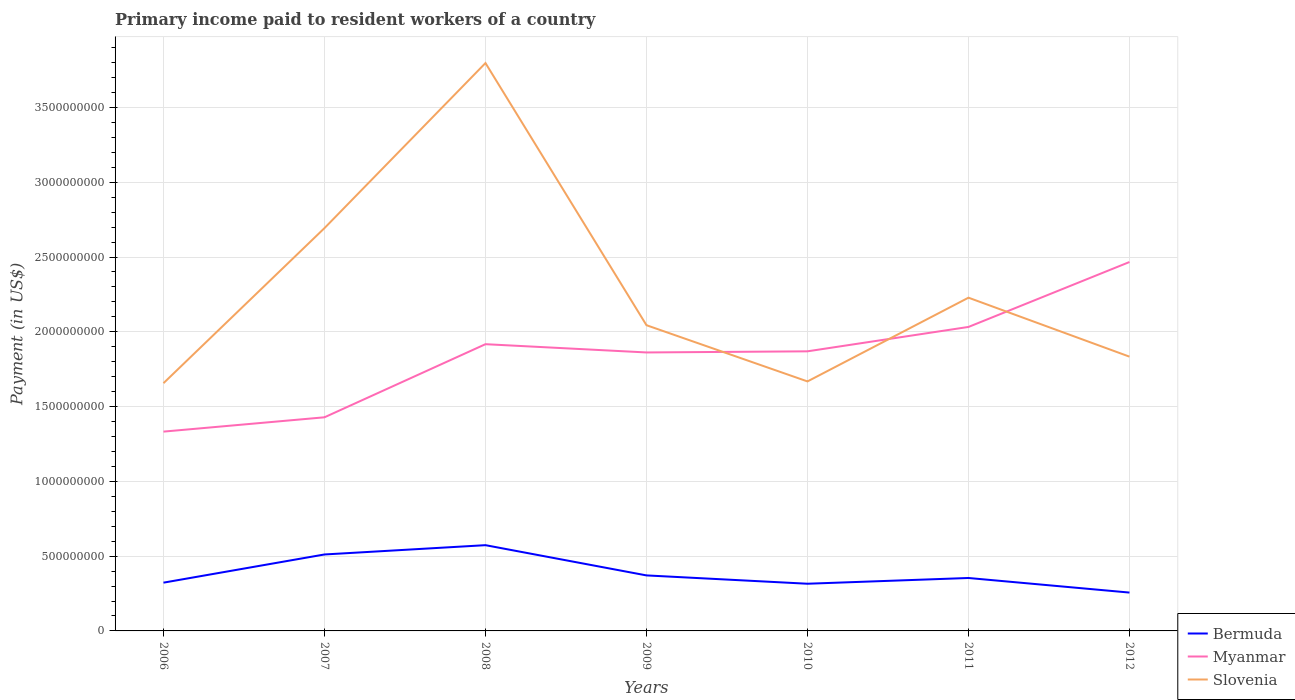How many different coloured lines are there?
Give a very brief answer. 3. Does the line corresponding to Myanmar intersect with the line corresponding to Slovenia?
Your response must be concise. Yes. Is the number of lines equal to the number of legend labels?
Give a very brief answer. Yes. Across all years, what is the maximum amount paid to workers in Slovenia?
Your answer should be compact. 1.66e+09. What is the total amount paid to workers in Bermuda in the graph?
Offer a very short reply. -6.21e+07. What is the difference between the highest and the second highest amount paid to workers in Bermuda?
Offer a terse response. 3.17e+08. What is the difference between the highest and the lowest amount paid to workers in Myanmar?
Provide a short and direct response. 5. Is the amount paid to workers in Bermuda strictly greater than the amount paid to workers in Slovenia over the years?
Keep it short and to the point. Yes. How many lines are there?
Provide a short and direct response. 3. How many years are there in the graph?
Provide a succinct answer. 7. What is the difference between two consecutive major ticks on the Y-axis?
Provide a succinct answer. 5.00e+08. Are the values on the major ticks of Y-axis written in scientific E-notation?
Offer a very short reply. No. Where does the legend appear in the graph?
Provide a short and direct response. Bottom right. How many legend labels are there?
Your answer should be compact. 3. How are the legend labels stacked?
Offer a terse response. Vertical. What is the title of the graph?
Ensure brevity in your answer.  Primary income paid to resident workers of a country. Does "Montenegro" appear as one of the legend labels in the graph?
Offer a terse response. No. What is the label or title of the Y-axis?
Provide a short and direct response. Payment (in US$). What is the Payment (in US$) of Bermuda in 2006?
Your answer should be compact. 3.23e+08. What is the Payment (in US$) in Myanmar in 2006?
Your answer should be very brief. 1.33e+09. What is the Payment (in US$) in Slovenia in 2006?
Your response must be concise. 1.66e+09. What is the Payment (in US$) of Bermuda in 2007?
Ensure brevity in your answer.  5.11e+08. What is the Payment (in US$) of Myanmar in 2007?
Offer a terse response. 1.43e+09. What is the Payment (in US$) of Slovenia in 2007?
Offer a very short reply. 2.69e+09. What is the Payment (in US$) of Bermuda in 2008?
Ensure brevity in your answer.  5.73e+08. What is the Payment (in US$) in Myanmar in 2008?
Offer a terse response. 1.92e+09. What is the Payment (in US$) of Slovenia in 2008?
Provide a succinct answer. 3.80e+09. What is the Payment (in US$) in Bermuda in 2009?
Make the answer very short. 3.71e+08. What is the Payment (in US$) of Myanmar in 2009?
Provide a succinct answer. 1.86e+09. What is the Payment (in US$) of Slovenia in 2009?
Provide a succinct answer. 2.04e+09. What is the Payment (in US$) in Bermuda in 2010?
Provide a succinct answer. 3.15e+08. What is the Payment (in US$) in Myanmar in 2010?
Your response must be concise. 1.87e+09. What is the Payment (in US$) of Slovenia in 2010?
Your answer should be very brief. 1.67e+09. What is the Payment (in US$) of Bermuda in 2011?
Provide a short and direct response. 3.54e+08. What is the Payment (in US$) of Myanmar in 2011?
Your response must be concise. 2.03e+09. What is the Payment (in US$) of Slovenia in 2011?
Keep it short and to the point. 2.23e+09. What is the Payment (in US$) of Bermuda in 2012?
Provide a short and direct response. 2.56e+08. What is the Payment (in US$) in Myanmar in 2012?
Ensure brevity in your answer.  2.47e+09. What is the Payment (in US$) in Slovenia in 2012?
Your answer should be compact. 1.83e+09. Across all years, what is the maximum Payment (in US$) in Bermuda?
Your answer should be compact. 5.73e+08. Across all years, what is the maximum Payment (in US$) in Myanmar?
Your answer should be very brief. 2.47e+09. Across all years, what is the maximum Payment (in US$) in Slovenia?
Ensure brevity in your answer.  3.80e+09. Across all years, what is the minimum Payment (in US$) in Bermuda?
Your response must be concise. 2.56e+08. Across all years, what is the minimum Payment (in US$) in Myanmar?
Your answer should be very brief. 1.33e+09. Across all years, what is the minimum Payment (in US$) of Slovenia?
Provide a short and direct response. 1.66e+09. What is the total Payment (in US$) in Bermuda in the graph?
Your answer should be very brief. 2.70e+09. What is the total Payment (in US$) in Myanmar in the graph?
Your answer should be compact. 1.29e+1. What is the total Payment (in US$) of Slovenia in the graph?
Keep it short and to the point. 1.59e+1. What is the difference between the Payment (in US$) of Bermuda in 2006 and that in 2007?
Offer a terse response. -1.88e+08. What is the difference between the Payment (in US$) in Myanmar in 2006 and that in 2007?
Your response must be concise. -9.57e+07. What is the difference between the Payment (in US$) of Slovenia in 2006 and that in 2007?
Provide a short and direct response. -1.04e+09. What is the difference between the Payment (in US$) of Bermuda in 2006 and that in 2008?
Provide a short and direct response. -2.51e+08. What is the difference between the Payment (in US$) of Myanmar in 2006 and that in 2008?
Give a very brief answer. -5.85e+08. What is the difference between the Payment (in US$) of Slovenia in 2006 and that in 2008?
Make the answer very short. -2.14e+09. What is the difference between the Payment (in US$) of Bermuda in 2006 and that in 2009?
Provide a short and direct response. -4.84e+07. What is the difference between the Payment (in US$) in Myanmar in 2006 and that in 2009?
Your answer should be compact. -5.29e+08. What is the difference between the Payment (in US$) of Slovenia in 2006 and that in 2009?
Give a very brief answer. -3.88e+08. What is the difference between the Payment (in US$) of Bermuda in 2006 and that in 2010?
Offer a very short reply. 7.28e+06. What is the difference between the Payment (in US$) of Myanmar in 2006 and that in 2010?
Your response must be concise. -5.37e+08. What is the difference between the Payment (in US$) of Slovenia in 2006 and that in 2010?
Keep it short and to the point. -1.18e+07. What is the difference between the Payment (in US$) of Bermuda in 2006 and that in 2011?
Ensure brevity in your answer.  -3.11e+07. What is the difference between the Payment (in US$) in Myanmar in 2006 and that in 2011?
Give a very brief answer. -7.00e+08. What is the difference between the Payment (in US$) in Slovenia in 2006 and that in 2011?
Your response must be concise. -5.72e+08. What is the difference between the Payment (in US$) of Bermuda in 2006 and that in 2012?
Ensure brevity in your answer.  6.63e+07. What is the difference between the Payment (in US$) in Myanmar in 2006 and that in 2012?
Provide a succinct answer. -1.13e+09. What is the difference between the Payment (in US$) in Slovenia in 2006 and that in 2012?
Offer a very short reply. -1.77e+08. What is the difference between the Payment (in US$) in Bermuda in 2007 and that in 2008?
Offer a very short reply. -6.21e+07. What is the difference between the Payment (in US$) in Myanmar in 2007 and that in 2008?
Provide a succinct answer. -4.89e+08. What is the difference between the Payment (in US$) of Slovenia in 2007 and that in 2008?
Make the answer very short. -1.10e+09. What is the difference between the Payment (in US$) in Bermuda in 2007 and that in 2009?
Offer a very short reply. 1.40e+08. What is the difference between the Payment (in US$) of Myanmar in 2007 and that in 2009?
Your answer should be compact. -4.34e+08. What is the difference between the Payment (in US$) of Slovenia in 2007 and that in 2009?
Provide a short and direct response. 6.49e+08. What is the difference between the Payment (in US$) in Bermuda in 2007 and that in 2010?
Your response must be concise. 1.96e+08. What is the difference between the Payment (in US$) in Myanmar in 2007 and that in 2010?
Offer a terse response. -4.41e+08. What is the difference between the Payment (in US$) in Slovenia in 2007 and that in 2010?
Provide a short and direct response. 1.03e+09. What is the difference between the Payment (in US$) of Bermuda in 2007 and that in 2011?
Your response must be concise. 1.57e+08. What is the difference between the Payment (in US$) of Myanmar in 2007 and that in 2011?
Offer a very short reply. -6.04e+08. What is the difference between the Payment (in US$) in Slovenia in 2007 and that in 2011?
Give a very brief answer. 4.65e+08. What is the difference between the Payment (in US$) of Bermuda in 2007 and that in 2012?
Keep it short and to the point. 2.55e+08. What is the difference between the Payment (in US$) of Myanmar in 2007 and that in 2012?
Ensure brevity in your answer.  -1.04e+09. What is the difference between the Payment (in US$) in Slovenia in 2007 and that in 2012?
Offer a very short reply. 8.59e+08. What is the difference between the Payment (in US$) in Bermuda in 2008 and that in 2009?
Make the answer very short. 2.02e+08. What is the difference between the Payment (in US$) in Myanmar in 2008 and that in 2009?
Keep it short and to the point. 5.53e+07. What is the difference between the Payment (in US$) of Slovenia in 2008 and that in 2009?
Provide a succinct answer. 1.75e+09. What is the difference between the Payment (in US$) of Bermuda in 2008 and that in 2010?
Offer a terse response. 2.58e+08. What is the difference between the Payment (in US$) of Myanmar in 2008 and that in 2010?
Make the answer very short. 4.77e+07. What is the difference between the Payment (in US$) in Slovenia in 2008 and that in 2010?
Your answer should be compact. 2.13e+09. What is the difference between the Payment (in US$) in Bermuda in 2008 and that in 2011?
Make the answer very short. 2.19e+08. What is the difference between the Payment (in US$) in Myanmar in 2008 and that in 2011?
Your response must be concise. -1.15e+08. What is the difference between the Payment (in US$) of Slovenia in 2008 and that in 2011?
Your answer should be compact. 1.57e+09. What is the difference between the Payment (in US$) of Bermuda in 2008 and that in 2012?
Provide a succinct answer. 3.17e+08. What is the difference between the Payment (in US$) of Myanmar in 2008 and that in 2012?
Give a very brief answer. -5.49e+08. What is the difference between the Payment (in US$) of Slovenia in 2008 and that in 2012?
Your response must be concise. 1.96e+09. What is the difference between the Payment (in US$) of Bermuda in 2009 and that in 2010?
Your answer should be very brief. 5.57e+07. What is the difference between the Payment (in US$) of Myanmar in 2009 and that in 2010?
Provide a succinct answer. -7.55e+06. What is the difference between the Payment (in US$) of Slovenia in 2009 and that in 2010?
Ensure brevity in your answer.  3.76e+08. What is the difference between the Payment (in US$) in Bermuda in 2009 and that in 2011?
Make the answer very short. 1.72e+07. What is the difference between the Payment (in US$) in Myanmar in 2009 and that in 2011?
Keep it short and to the point. -1.71e+08. What is the difference between the Payment (in US$) of Slovenia in 2009 and that in 2011?
Offer a very short reply. -1.84e+08. What is the difference between the Payment (in US$) of Bermuda in 2009 and that in 2012?
Your answer should be compact. 1.15e+08. What is the difference between the Payment (in US$) in Myanmar in 2009 and that in 2012?
Offer a very short reply. -6.05e+08. What is the difference between the Payment (in US$) in Slovenia in 2009 and that in 2012?
Offer a very short reply. 2.10e+08. What is the difference between the Payment (in US$) of Bermuda in 2010 and that in 2011?
Ensure brevity in your answer.  -3.84e+07. What is the difference between the Payment (in US$) of Myanmar in 2010 and that in 2011?
Your answer should be very brief. -1.63e+08. What is the difference between the Payment (in US$) of Slovenia in 2010 and that in 2011?
Your answer should be very brief. -5.60e+08. What is the difference between the Payment (in US$) of Bermuda in 2010 and that in 2012?
Give a very brief answer. 5.90e+07. What is the difference between the Payment (in US$) of Myanmar in 2010 and that in 2012?
Your answer should be compact. -5.97e+08. What is the difference between the Payment (in US$) of Slovenia in 2010 and that in 2012?
Your answer should be compact. -1.66e+08. What is the difference between the Payment (in US$) of Bermuda in 2011 and that in 2012?
Your answer should be compact. 9.75e+07. What is the difference between the Payment (in US$) of Myanmar in 2011 and that in 2012?
Provide a succinct answer. -4.34e+08. What is the difference between the Payment (in US$) of Slovenia in 2011 and that in 2012?
Ensure brevity in your answer.  3.94e+08. What is the difference between the Payment (in US$) in Bermuda in 2006 and the Payment (in US$) in Myanmar in 2007?
Offer a terse response. -1.11e+09. What is the difference between the Payment (in US$) of Bermuda in 2006 and the Payment (in US$) of Slovenia in 2007?
Offer a terse response. -2.37e+09. What is the difference between the Payment (in US$) of Myanmar in 2006 and the Payment (in US$) of Slovenia in 2007?
Provide a succinct answer. -1.36e+09. What is the difference between the Payment (in US$) in Bermuda in 2006 and the Payment (in US$) in Myanmar in 2008?
Provide a succinct answer. -1.59e+09. What is the difference between the Payment (in US$) of Bermuda in 2006 and the Payment (in US$) of Slovenia in 2008?
Provide a succinct answer. -3.47e+09. What is the difference between the Payment (in US$) in Myanmar in 2006 and the Payment (in US$) in Slovenia in 2008?
Make the answer very short. -2.46e+09. What is the difference between the Payment (in US$) of Bermuda in 2006 and the Payment (in US$) of Myanmar in 2009?
Your answer should be very brief. -1.54e+09. What is the difference between the Payment (in US$) of Bermuda in 2006 and the Payment (in US$) of Slovenia in 2009?
Give a very brief answer. -1.72e+09. What is the difference between the Payment (in US$) of Myanmar in 2006 and the Payment (in US$) of Slovenia in 2009?
Offer a terse response. -7.11e+08. What is the difference between the Payment (in US$) of Bermuda in 2006 and the Payment (in US$) of Myanmar in 2010?
Offer a terse response. -1.55e+09. What is the difference between the Payment (in US$) in Bermuda in 2006 and the Payment (in US$) in Slovenia in 2010?
Ensure brevity in your answer.  -1.35e+09. What is the difference between the Payment (in US$) in Myanmar in 2006 and the Payment (in US$) in Slovenia in 2010?
Ensure brevity in your answer.  -3.36e+08. What is the difference between the Payment (in US$) in Bermuda in 2006 and the Payment (in US$) in Myanmar in 2011?
Your answer should be compact. -1.71e+09. What is the difference between the Payment (in US$) of Bermuda in 2006 and the Payment (in US$) of Slovenia in 2011?
Offer a terse response. -1.91e+09. What is the difference between the Payment (in US$) in Myanmar in 2006 and the Payment (in US$) in Slovenia in 2011?
Keep it short and to the point. -8.95e+08. What is the difference between the Payment (in US$) in Bermuda in 2006 and the Payment (in US$) in Myanmar in 2012?
Provide a succinct answer. -2.14e+09. What is the difference between the Payment (in US$) in Bermuda in 2006 and the Payment (in US$) in Slovenia in 2012?
Ensure brevity in your answer.  -1.51e+09. What is the difference between the Payment (in US$) of Myanmar in 2006 and the Payment (in US$) of Slovenia in 2012?
Give a very brief answer. -5.01e+08. What is the difference between the Payment (in US$) of Bermuda in 2007 and the Payment (in US$) of Myanmar in 2008?
Provide a short and direct response. -1.41e+09. What is the difference between the Payment (in US$) in Bermuda in 2007 and the Payment (in US$) in Slovenia in 2008?
Your answer should be compact. -3.29e+09. What is the difference between the Payment (in US$) in Myanmar in 2007 and the Payment (in US$) in Slovenia in 2008?
Ensure brevity in your answer.  -2.37e+09. What is the difference between the Payment (in US$) in Bermuda in 2007 and the Payment (in US$) in Myanmar in 2009?
Your answer should be compact. -1.35e+09. What is the difference between the Payment (in US$) in Bermuda in 2007 and the Payment (in US$) in Slovenia in 2009?
Provide a succinct answer. -1.53e+09. What is the difference between the Payment (in US$) in Myanmar in 2007 and the Payment (in US$) in Slovenia in 2009?
Keep it short and to the point. -6.16e+08. What is the difference between the Payment (in US$) in Bermuda in 2007 and the Payment (in US$) in Myanmar in 2010?
Your answer should be very brief. -1.36e+09. What is the difference between the Payment (in US$) of Bermuda in 2007 and the Payment (in US$) of Slovenia in 2010?
Provide a succinct answer. -1.16e+09. What is the difference between the Payment (in US$) in Myanmar in 2007 and the Payment (in US$) in Slovenia in 2010?
Offer a very short reply. -2.40e+08. What is the difference between the Payment (in US$) in Bermuda in 2007 and the Payment (in US$) in Myanmar in 2011?
Give a very brief answer. -1.52e+09. What is the difference between the Payment (in US$) in Bermuda in 2007 and the Payment (in US$) in Slovenia in 2011?
Keep it short and to the point. -1.72e+09. What is the difference between the Payment (in US$) in Myanmar in 2007 and the Payment (in US$) in Slovenia in 2011?
Offer a very short reply. -8.00e+08. What is the difference between the Payment (in US$) of Bermuda in 2007 and the Payment (in US$) of Myanmar in 2012?
Offer a terse response. -1.96e+09. What is the difference between the Payment (in US$) of Bermuda in 2007 and the Payment (in US$) of Slovenia in 2012?
Make the answer very short. -1.32e+09. What is the difference between the Payment (in US$) in Myanmar in 2007 and the Payment (in US$) in Slovenia in 2012?
Your response must be concise. -4.05e+08. What is the difference between the Payment (in US$) in Bermuda in 2008 and the Payment (in US$) in Myanmar in 2009?
Your response must be concise. -1.29e+09. What is the difference between the Payment (in US$) of Bermuda in 2008 and the Payment (in US$) of Slovenia in 2009?
Offer a terse response. -1.47e+09. What is the difference between the Payment (in US$) of Myanmar in 2008 and the Payment (in US$) of Slovenia in 2009?
Your response must be concise. -1.27e+08. What is the difference between the Payment (in US$) in Bermuda in 2008 and the Payment (in US$) in Myanmar in 2010?
Provide a short and direct response. -1.30e+09. What is the difference between the Payment (in US$) in Bermuda in 2008 and the Payment (in US$) in Slovenia in 2010?
Offer a terse response. -1.09e+09. What is the difference between the Payment (in US$) in Myanmar in 2008 and the Payment (in US$) in Slovenia in 2010?
Provide a short and direct response. 2.49e+08. What is the difference between the Payment (in US$) in Bermuda in 2008 and the Payment (in US$) in Myanmar in 2011?
Keep it short and to the point. -1.46e+09. What is the difference between the Payment (in US$) of Bermuda in 2008 and the Payment (in US$) of Slovenia in 2011?
Your answer should be compact. -1.65e+09. What is the difference between the Payment (in US$) of Myanmar in 2008 and the Payment (in US$) of Slovenia in 2011?
Your answer should be very brief. -3.11e+08. What is the difference between the Payment (in US$) in Bermuda in 2008 and the Payment (in US$) in Myanmar in 2012?
Your answer should be compact. -1.89e+09. What is the difference between the Payment (in US$) of Bermuda in 2008 and the Payment (in US$) of Slovenia in 2012?
Your response must be concise. -1.26e+09. What is the difference between the Payment (in US$) of Myanmar in 2008 and the Payment (in US$) of Slovenia in 2012?
Your answer should be very brief. 8.34e+07. What is the difference between the Payment (in US$) in Bermuda in 2009 and the Payment (in US$) in Myanmar in 2010?
Make the answer very short. -1.50e+09. What is the difference between the Payment (in US$) of Bermuda in 2009 and the Payment (in US$) of Slovenia in 2010?
Give a very brief answer. -1.30e+09. What is the difference between the Payment (in US$) of Myanmar in 2009 and the Payment (in US$) of Slovenia in 2010?
Keep it short and to the point. 1.94e+08. What is the difference between the Payment (in US$) of Bermuda in 2009 and the Payment (in US$) of Myanmar in 2011?
Offer a very short reply. -1.66e+09. What is the difference between the Payment (in US$) of Bermuda in 2009 and the Payment (in US$) of Slovenia in 2011?
Give a very brief answer. -1.86e+09. What is the difference between the Payment (in US$) in Myanmar in 2009 and the Payment (in US$) in Slovenia in 2011?
Your answer should be very brief. -3.66e+08. What is the difference between the Payment (in US$) in Bermuda in 2009 and the Payment (in US$) in Myanmar in 2012?
Provide a short and direct response. -2.10e+09. What is the difference between the Payment (in US$) of Bermuda in 2009 and the Payment (in US$) of Slovenia in 2012?
Your response must be concise. -1.46e+09. What is the difference between the Payment (in US$) in Myanmar in 2009 and the Payment (in US$) in Slovenia in 2012?
Provide a short and direct response. 2.81e+07. What is the difference between the Payment (in US$) of Bermuda in 2010 and the Payment (in US$) of Myanmar in 2011?
Provide a short and direct response. -1.72e+09. What is the difference between the Payment (in US$) in Bermuda in 2010 and the Payment (in US$) in Slovenia in 2011?
Offer a very short reply. -1.91e+09. What is the difference between the Payment (in US$) in Myanmar in 2010 and the Payment (in US$) in Slovenia in 2011?
Ensure brevity in your answer.  -3.59e+08. What is the difference between the Payment (in US$) of Bermuda in 2010 and the Payment (in US$) of Myanmar in 2012?
Provide a short and direct response. -2.15e+09. What is the difference between the Payment (in US$) of Bermuda in 2010 and the Payment (in US$) of Slovenia in 2012?
Your response must be concise. -1.52e+09. What is the difference between the Payment (in US$) of Myanmar in 2010 and the Payment (in US$) of Slovenia in 2012?
Offer a terse response. 3.56e+07. What is the difference between the Payment (in US$) in Bermuda in 2011 and the Payment (in US$) in Myanmar in 2012?
Provide a short and direct response. -2.11e+09. What is the difference between the Payment (in US$) of Bermuda in 2011 and the Payment (in US$) of Slovenia in 2012?
Ensure brevity in your answer.  -1.48e+09. What is the difference between the Payment (in US$) of Myanmar in 2011 and the Payment (in US$) of Slovenia in 2012?
Make the answer very short. 1.99e+08. What is the average Payment (in US$) of Bermuda per year?
Provide a short and direct response. 3.86e+08. What is the average Payment (in US$) in Myanmar per year?
Ensure brevity in your answer.  1.84e+09. What is the average Payment (in US$) of Slovenia per year?
Your answer should be compact. 2.27e+09. In the year 2006, what is the difference between the Payment (in US$) of Bermuda and Payment (in US$) of Myanmar?
Offer a terse response. -1.01e+09. In the year 2006, what is the difference between the Payment (in US$) in Bermuda and Payment (in US$) in Slovenia?
Offer a very short reply. -1.33e+09. In the year 2006, what is the difference between the Payment (in US$) in Myanmar and Payment (in US$) in Slovenia?
Your answer should be very brief. -3.24e+08. In the year 2007, what is the difference between the Payment (in US$) in Bermuda and Payment (in US$) in Myanmar?
Ensure brevity in your answer.  -9.17e+08. In the year 2007, what is the difference between the Payment (in US$) of Bermuda and Payment (in US$) of Slovenia?
Your answer should be very brief. -2.18e+09. In the year 2007, what is the difference between the Payment (in US$) of Myanmar and Payment (in US$) of Slovenia?
Your response must be concise. -1.26e+09. In the year 2008, what is the difference between the Payment (in US$) in Bermuda and Payment (in US$) in Myanmar?
Offer a very short reply. -1.34e+09. In the year 2008, what is the difference between the Payment (in US$) in Bermuda and Payment (in US$) in Slovenia?
Provide a short and direct response. -3.22e+09. In the year 2008, what is the difference between the Payment (in US$) in Myanmar and Payment (in US$) in Slovenia?
Give a very brief answer. -1.88e+09. In the year 2009, what is the difference between the Payment (in US$) in Bermuda and Payment (in US$) in Myanmar?
Offer a very short reply. -1.49e+09. In the year 2009, what is the difference between the Payment (in US$) of Bermuda and Payment (in US$) of Slovenia?
Keep it short and to the point. -1.67e+09. In the year 2009, what is the difference between the Payment (in US$) of Myanmar and Payment (in US$) of Slovenia?
Offer a terse response. -1.82e+08. In the year 2010, what is the difference between the Payment (in US$) of Bermuda and Payment (in US$) of Myanmar?
Ensure brevity in your answer.  -1.55e+09. In the year 2010, what is the difference between the Payment (in US$) in Bermuda and Payment (in US$) in Slovenia?
Your answer should be very brief. -1.35e+09. In the year 2010, what is the difference between the Payment (in US$) of Myanmar and Payment (in US$) of Slovenia?
Your answer should be very brief. 2.01e+08. In the year 2011, what is the difference between the Payment (in US$) of Bermuda and Payment (in US$) of Myanmar?
Offer a terse response. -1.68e+09. In the year 2011, what is the difference between the Payment (in US$) of Bermuda and Payment (in US$) of Slovenia?
Provide a short and direct response. -1.87e+09. In the year 2011, what is the difference between the Payment (in US$) of Myanmar and Payment (in US$) of Slovenia?
Give a very brief answer. -1.96e+08. In the year 2012, what is the difference between the Payment (in US$) of Bermuda and Payment (in US$) of Myanmar?
Provide a succinct answer. -2.21e+09. In the year 2012, what is the difference between the Payment (in US$) in Bermuda and Payment (in US$) in Slovenia?
Your answer should be very brief. -1.58e+09. In the year 2012, what is the difference between the Payment (in US$) of Myanmar and Payment (in US$) of Slovenia?
Keep it short and to the point. 6.33e+08. What is the ratio of the Payment (in US$) in Bermuda in 2006 to that in 2007?
Your response must be concise. 0.63. What is the ratio of the Payment (in US$) of Myanmar in 2006 to that in 2007?
Provide a succinct answer. 0.93. What is the ratio of the Payment (in US$) of Slovenia in 2006 to that in 2007?
Ensure brevity in your answer.  0.61. What is the ratio of the Payment (in US$) in Bermuda in 2006 to that in 2008?
Your response must be concise. 0.56. What is the ratio of the Payment (in US$) in Myanmar in 2006 to that in 2008?
Your answer should be compact. 0.7. What is the ratio of the Payment (in US$) in Slovenia in 2006 to that in 2008?
Give a very brief answer. 0.44. What is the ratio of the Payment (in US$) in Bermuda in 2006 to that in 2009?
Your response must be concise. 0.87. What is the ratio of the Payment (in US$) in Myanmar in 2006 to that in 2009?
Ensure brevity in your answer.  0.72. What is the ratio of the Payment (in US$) of Slovenia in 2006 to that in 2009?
Provide a short and direct response. 0.81. What is the ratio of the Payment (in US$) in Bermuda in 2006 to that in 2010?
Offer a very short reply. 1.02. What is the ratio of the Payment (in US$) in Myanmar in 2006 to that in 2010?
Keep it short and to the point. 0.71. What is the ratio of the Payment (in US$) in Slovenia in 2006 to that in 2010?
Offer a terse response. 0.99. What is the ratio of the Payment (in US$) in Bermuda in 2006 to that in 2011?
Provide a short and direct response. 0.91. What is the ratio of the Payment (in US$) of Myanmar in 2006 to that in 2011?
Your answer should be compact. 0.66. What is the ratio of the Payment (in US$) in Slovenia in 2006 to that in 2011?
Provide a short and direct response. 0.74. What is the ratio of the Payment (in US$) in Bermuda in 2006 to that in 2012?
Make the answer very short. 1.26. What is the ratio of the Payment (in US$) of Myanmar in 2006 to that in 2012?
Your answer should be compact. 0.54. What is the ratio of the Payment (in US$) of Slovenia in 2006 to that in 2012?
Your answer should be compact. 0.9. What is the ratio of the Payment (in US$) of Bermuda in 2007 to that in 2008?
Offer a terse response. 0.89. What is the ratio of the Payment (in US$) of Myanmar in 2007 to that in 2008?
Give a very brief answer. 0.74. What is the ratio of the Payment (in US$) in Slovenia in 2007 to that in 2008?
Keep it short and to the point. 0.71. What is the ratio of the Payment (in US$) in Bermuda in 2007 to that in 2009?
Provide a succinct answer. 1.38. What is the ratio of the Payment (in US$) in Myanmar in 2007 to that in 2009?
Your answer should be compact. 0.77. What is the ratio of the Payment (in US$) in Slovenia in 2007 to that in 2009?
Your answer should be compact. 1.32. What is the ratio of the Payment (in US$) of Bermuda in 2007 to that in 2010?
Your response must be concise. 1.62. What is the ratio of the Payment (in US$) in Myanmar in 2007 to that in 2010?
Offer a very short reply. 0.76. What is the ratio of the Payment (in US$) of Slovenia in 2007 to that in 2010?
Your answer should be compact. 1.61. What is the ratio of the Payment (in US$) of Bermuda in 2007 to that in 2011?
Provide a succinct answer. 1.44. What is the ratio of the Payment (in US$) of Myanmar in 2007 to that in 2011?
Your response must be concise. 0.7. What is the ratio of the Payment (in US$) in Slovenia in 2007 to that in 2011?
Give a very brief answer. 1.21. What is the ratio of the Payment (in US$) in Bermuda in 2007 to that in 2012?
Your response must be concise. 1.99. What is the ratio of the Payment (in US$) in Myanmar in 2007 to that in 2012?
Offer a terse response. 0.58. What is the ratio of the Payment (in US$) of Slovenia in 2007 to that in 2012?
Your answer should be compact. 1.47. What is the ratio of the Payment (in US$) in Bermuda in 2008 to that in 2009?
Give a very brief answer. 1.54. What is the ratio of the Payment (in US$) in Myanmar in 2008 to that in 2009?
Give a very brief answer. 1.03. What is the ratio of the Payment (in US$) of Slovenia in 2008 to that in 2009?
Your response must be concise. 1.86. What is the ratio of the Payment (in US$) in Bermuda in 2008 to that in 2010?
Your answer should be very brief. 1.82. What is the ratio of the Payment (in US$) of Myanmar in 2008 to that in 2010?
Offer a terse response. 1.03. What is the ratio of the Payment (in US$) of Slovenia in 2008 to that in 2010?
Provide a succinct answer. 2.28. What is the ratio of the Payment (in US$) in Bermuda in 2008 to that in 2011?
Offer a very short reply. 1.62. What is the ratio of the Payment (in US$) of Myanmar in 2008 to that in 2011?
Provide a short and direct response. 0.94. What is the ratio of the Payment (in US$) in Slovenia in 2008 to that in 2011?
Give a very brief answer. 1.7. What is the ratio of the Payment (in US$) in Bermuda in 2008 to that in 2012?
Your response must be concise. 2.24. What is the ratio of the Payment (in US$) in Myanmar in 2008 to that in 2012?
Provide a succinct answer. 0.78. What is the ratio of the Payment (in US$) in Slovenia in 2008 to that in 2012?
Ensure brevity in your answer.  2.07. What is the ratio of the Payment (in US$) of Bermuda in 2009 to that in 2010?
Provide a succinct answer. 1.18. What is the ratio of the Payment (in US$) of Myanmar in 2009 to that in 2010?
Keep it short and to the point. 1. What is the ratio of the Payment (in US$) in Slovenia in 2009 to that in 2010?
Ensure brevity in your answer.  1.23. What is the ratio of the Payment (in US$) of Bermuda in 2009 to that in 2011?
Provide a short and direct response. 1.05. What is the ratio of the Payment (in US$) in Myanmar in 2009 to that in 2011?
Your answer should be very brief. 0.92. What is the ratio of the Payment (in US$) in Slovenia in 2009 to that in 2011?
Make the answer very short. 0.92. What is the ratio of the Payment (in US$) in Bermuda in 2009 to that in 2012?
Keep it short and to the point. 1.45. What is the ratio of the Payment (in US$) in Myanmar in 2009 to that in 2012?
Your answer should be very brief. 0.75. What is the ratio of the Payment (in US$) in Slovenia in 2009 to that in 2012?
Keep it short and to the point. 1.11. What is the ratio of the Payment (in US$) of Bermuda in 2010 to that in 2011?
Make the answer very short. 0.89. What is the ratio of the Payment (in US$) of Myanmar in 2010 to that in 2011?
Provide a succinct answer. 0.92. What is the ratio of the Payment (in US$) of Slovenia in 2010 to that in 2011?
Your answer should be very brief. 0.75. What is the ratio of the Payment (in US$) in Bermuda in 2010 to that in 2012?
Offer a very short reply. 1.23. What is the ratio of the Payment (in US$) of Myanmar in 2010 to that in 2012?
Ensure brevity in your answer.  0.76. What is the ratio of the Payment (in US$) of Slovenia in 2010 to that in 2012?
Your answer should be very brief. 0.91. What is the ratio of the Payment (in US$) of Bermuda in 2011 to that in 2012?
Provide a short and direct response. 1.38. What is the ratio of the Payment (in US$) in Myanmar in 2011 to that in 2012?
Offer a terse response. 0.82. What is the ratio of the Payment (in US$) in Slovenia in 2011 to that in 2012?
Ensure brevity in your answer.  1.22. What is the difference between the highest and the second highest Payment (in US$) in Bermuda?
Give a very brief answer. 6.21e+07. What is the difference between the highest and the second highest Payment (in US$) of Myanmar?
Offer a very short reply. 4.34e+08. What is the difference between the highest and the second highest Payment (in US$) in Slovenia?
Your response must be concise. 1.10e+09. What is the difference between the highest and the lowest Payment (in US$) of Bermuda?
Provide a succinct answer. 3.17e+08. What is the difference between the highest and the lowest Payment (in US$) in Myanmar?
Offer a terse response. 1.13e+09. What is the difference between the highest and the lowest Payment (in US$) in Slovenia?
Your answer should be very brief. 2.14e+09. 